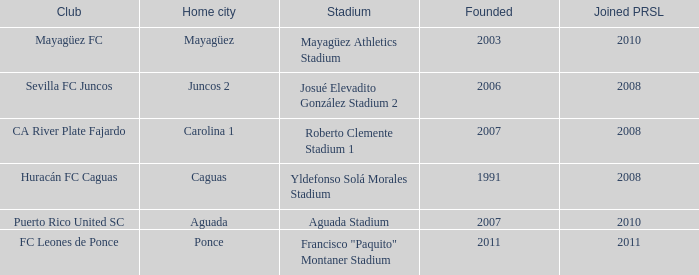What is the club that was founded before 2007, joined prsl in 2008 and the stadium is yldefonso solá morales stadium? Huracán FC Caguas. 